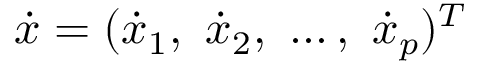<formula> <loc_0><loc_0><loc_500><loc_500>\dot { x } = ( \dot { x } _ { 1 } , \ \dot { x } _ { 2 } , \ \dots , \ \dot { x } _ { p } ) ^ { T }</formula> 